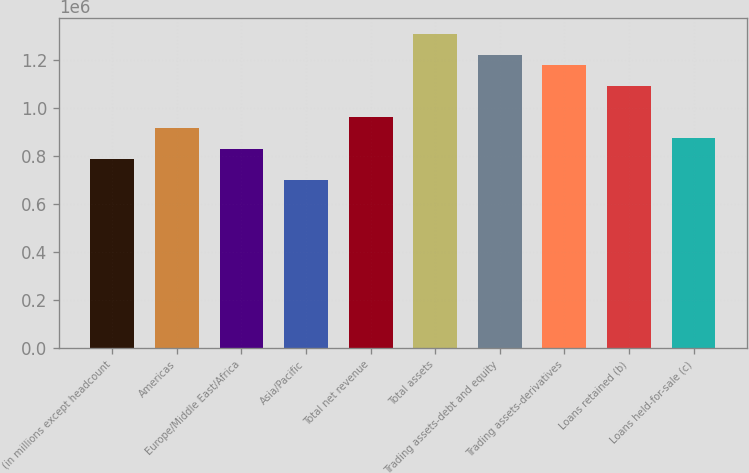Convert chart. <chart><loc_0><loc_0><loc_500><loc_500><bar_chart><fcel>(in millions except headcount<fcel>Americas<fcel>Europe/Middle East/Africa<fcel>Asia/Pacific<fcel>Total net revenue<fcel>Total assets<fcel>Trading assets-debt and equity<fcel>Trading assets-derivatives<fcel>Loans retained (b)<fcel>Loans held-for-sale (c)<nl><fcel>785677<fcel>916623<fcel>829326<fcel>698380<fcel>960272<fcel>1.30946e+06<fcel>1.22216e+06<fcel>1.17851e+06<fcel>1.09122e+06<fcel>872974<nl></chart> 